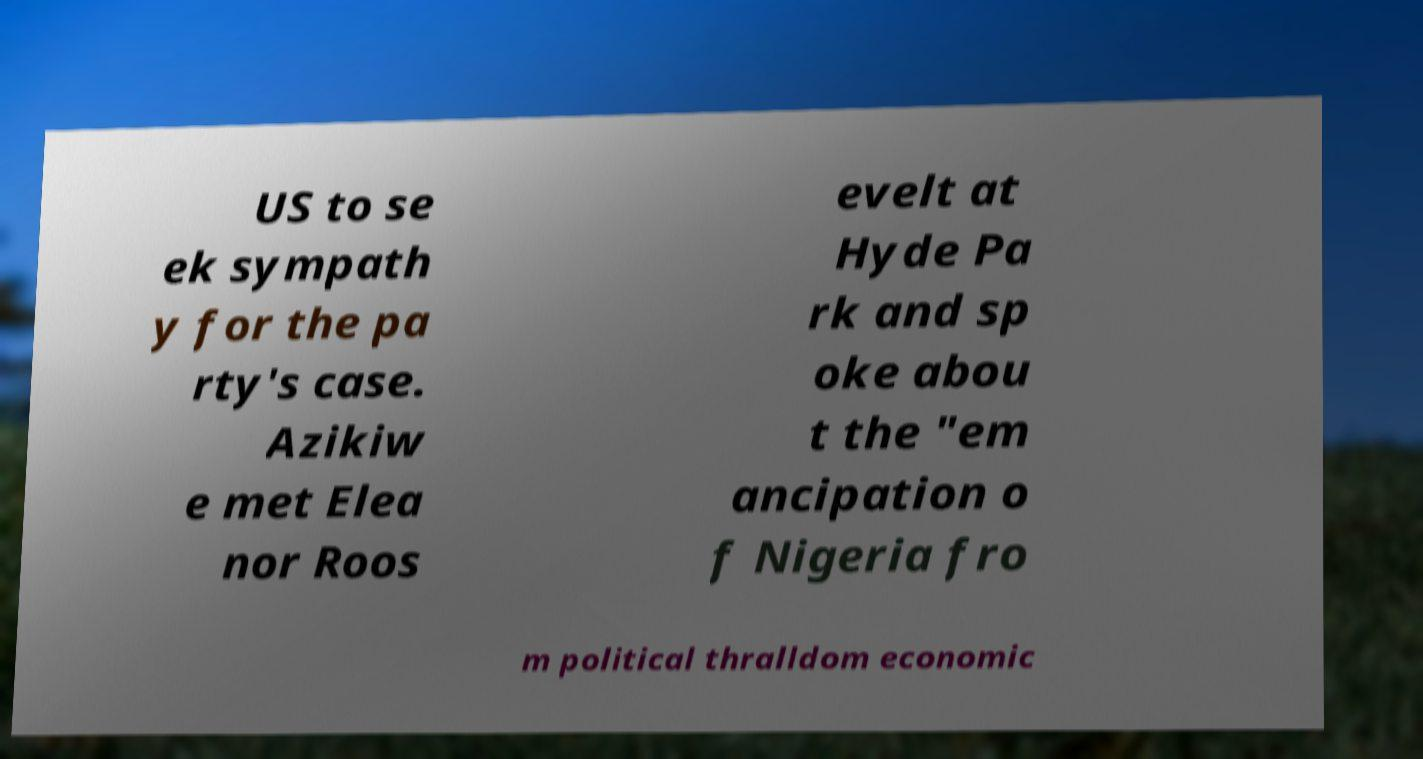Could you extract and type out the text from this image? US to se ek sympath y for the pa rty's case. Azikiw e met Elea nor Roos evelt at Hyde Pa rk and sp oke abou t the "em ancipation o f Nigeria fro m political thralldom economic 